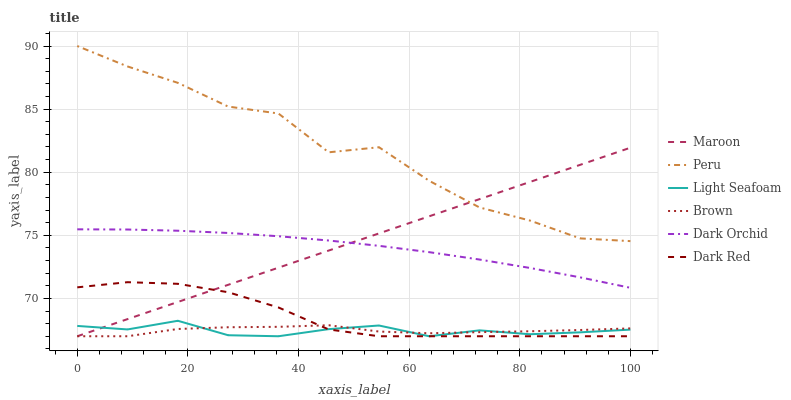Does Dark Red have the minimum area under the curve?
Answer yes or no. No. Does Dark Red have the maximum area under the curve?
Answer yes or no. No. Is Dark Red the smoothest?
Answer yes or no. No. Is Dark Red the roughest?
Answer yes or no. No. Does Dark Orchid have the lowest value?
Answer yes or no. No. Does Dark Red have the highest value?
Answer yes or no. No. Is Dark Red less than Peru?
Answer yes or no. Yes. Is Peru greater than Brown?
Answer yes or no. Yes. Does Dark Red intersect Peru?
Answer yes or no. No. 